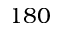Convert formula to latex. <formula><loc_0><loc_0><loc_500><loc_500>1 8 0</formula> 